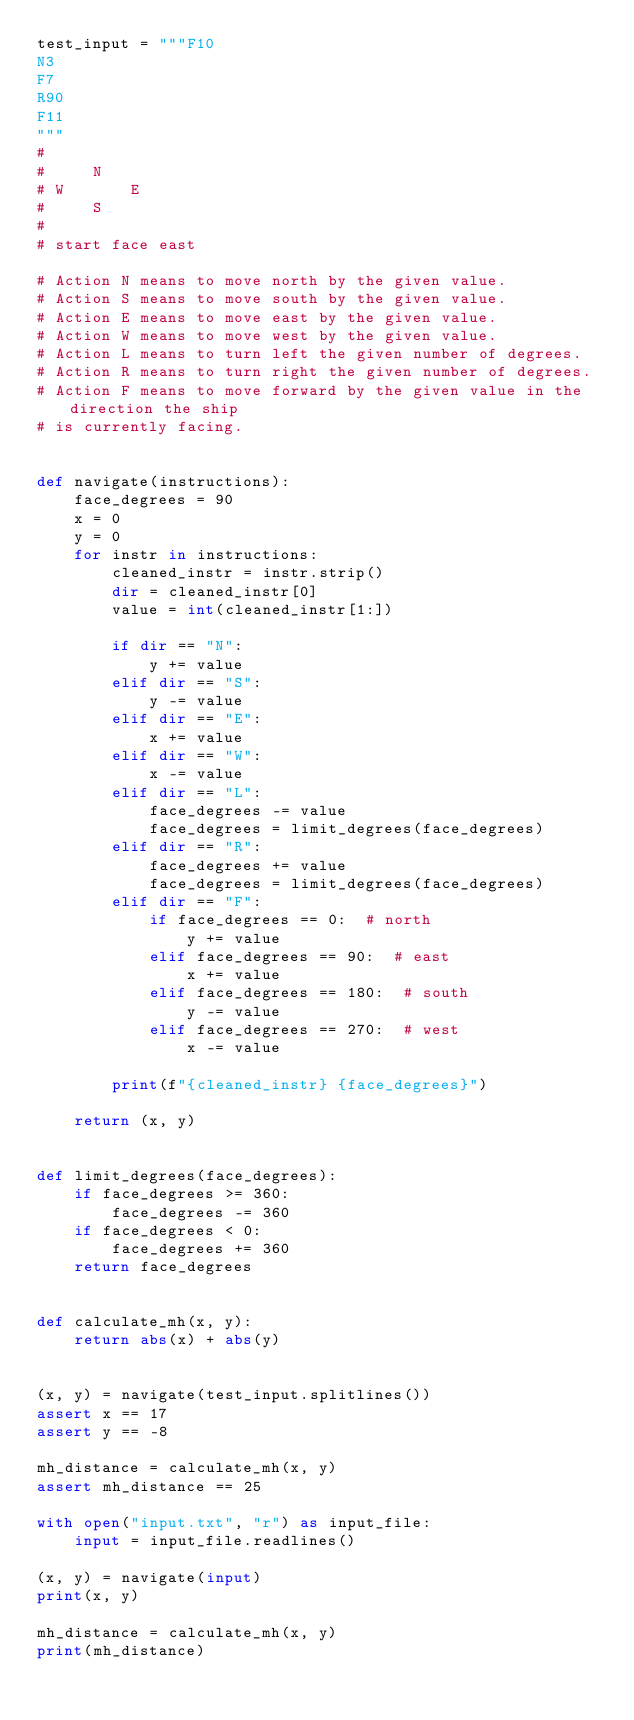Convert code to text. <code><loc_0><loc_0><loc_500><loc_500><_Python_>test_input = """F10
N3
F7
R90
F11
"""
#
#     N
# W       E
#     S
#
# start face east

# Action N means to move north by the given value.
# Action S means to move south by the given value.
# Action E means to move east by the given value.
# Action W means to move west by the given value.
# Action L means to turn left the given number of degrees.
# Action R means to turn right the given number of degrees.
# Action F means to move forward by the given value in the direction the ship
# is currently facing.


def navigate(instructions):
    face_degrees = 90
    x = 0
    y = 0
    for instr in instructions:
        cleaned_instr = instr.strip()
        dir = cleaned_instr[0]
        value = int(cleaned_instr[1:])

        if dir == "N":
            y += value
        elif dir == "S":
            y -= value
        elif dir == "E":
            x += value
        elif dir == "W":
            x -= value
        elif dir == "L":
            face_degrees -= value
            face_degrees = limit_degrees(face_degrees)
        elif dir == "R":
            face_degrees += value
            face_degrees = limit_degrees(face_degrees)
        elif dir == "F":
            if face_degrees == 0:  # north
                y += value
            elif face_degrees == 90:  # east
                x += value
            elif face_degrees == 180:  # south
                y -= value
            elif face_degrees == 270:  # west
                x -= value

        print(f"{cleaned_instr} {face_degrees}")

    return (x, y)


def limit_degrees(face_degrees):
    if face_degrees >= 360:
        face_degrees -= 360
    if face_degrees < 0:
        face_degrees += 360
    return face_degrees


def calculate_mh(x, y):
    return abs(x) + abs(y)


(x, y) = navigate(test_input.splitlines())
assert x == 17
assert y == -8

mh_distance = calculate_mh(x, y)
assert mh_distance == 25

with open("input.txt", "r") as input_file:
    input = input_file.readlines()

(x, y) = navigate(input)
print(x, y)

mh_distance = calculate_mh(x, y)
print(mh_distance)
</code> 